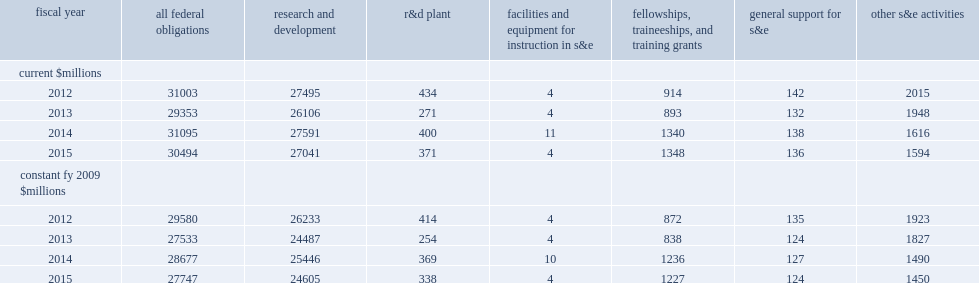I n fy 2015, how many million dollars did federal agencies obligate to 1,016 academic institutions for science and engineering (s&e) activities? 30494.0. How many percent of decrease in current dollars from the $31.1 billion obligated to 1,003 academic institutions in fy 2014? -0.019328. I n fy 2014, how many million dollars did federal agencies obligate to 1,003 academic institutions for science and engineering (s&e) activities? 31095.0. After adjusting for inflation, how many million dollars did federal s&e obligations to academic institutions decrease between fy 2014 and fy 2015? -930. After adjusting for inflation, how many million dollars did federal s&e obligations to academic institutions increase from fy 2013 to fy 2014? 1144. 